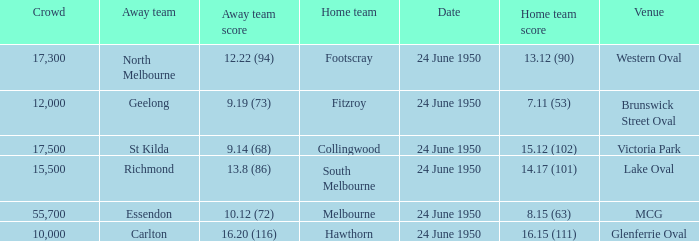Parse the full table. {'header': ['Crowd', 'Away team', 'Away team score', 'Home team', 'Date', 'Home team score', 'Venue'], 'rows': [['17,300', 'North Melbourne', '12.22 (94)', 'Footscray', '24 June 1950', '13.12 (90)', 'Western Oval'], ['12,000', 'Geelong', '9.19 (73)', 'Fitzroy', '24 June 1950', '7.11 (53)', 'Brunswick Street Oval'], ['17,500', 'St Kilda', '9.14 (68)', 'Collingwood', '24 June 1950', '15.12 (102)', 'Victoria Park'], ['15,500', 'Richmond', '13.8 (86)', 'South Melbourne', '24 June 1950', '14.17 (101)', 'Lake Oval'], ['55,700', 'Essendon', '10.12 (72)', 'Melbourne', '24 June 1950', '8.15 (63)', 'MCG'], ['10,000', 'Carlton', '16.20 (116)', 'Hawthorn', '24 June 1950', '16.15 (111)', 'Glenferrie Oval']]} Who was the hosting team in the game where north melbourne participated as the away team? Footscray. 